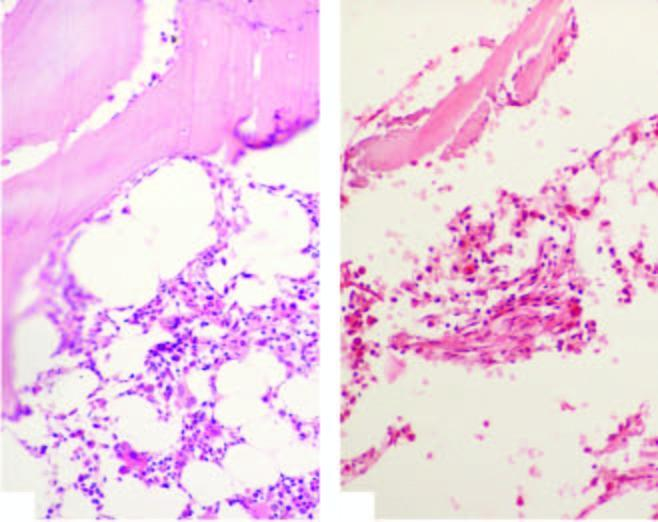re the alveolar lumina scanty foci of cellular components composed chiefly of lymphoid cells?
Answer the question using a single word or phrase. No 